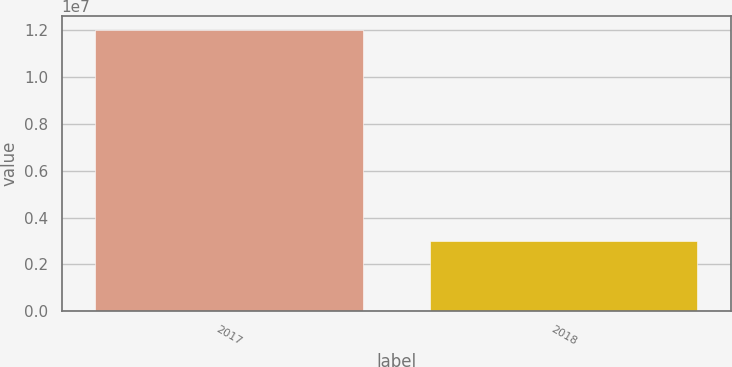<chart> <loc_0><loc_0><loc_500><loc_500><bar_chart><fcel>2017<fcel>2018<nl><fcel>1.2e+07<fcel>3e+06<nl></chart> 